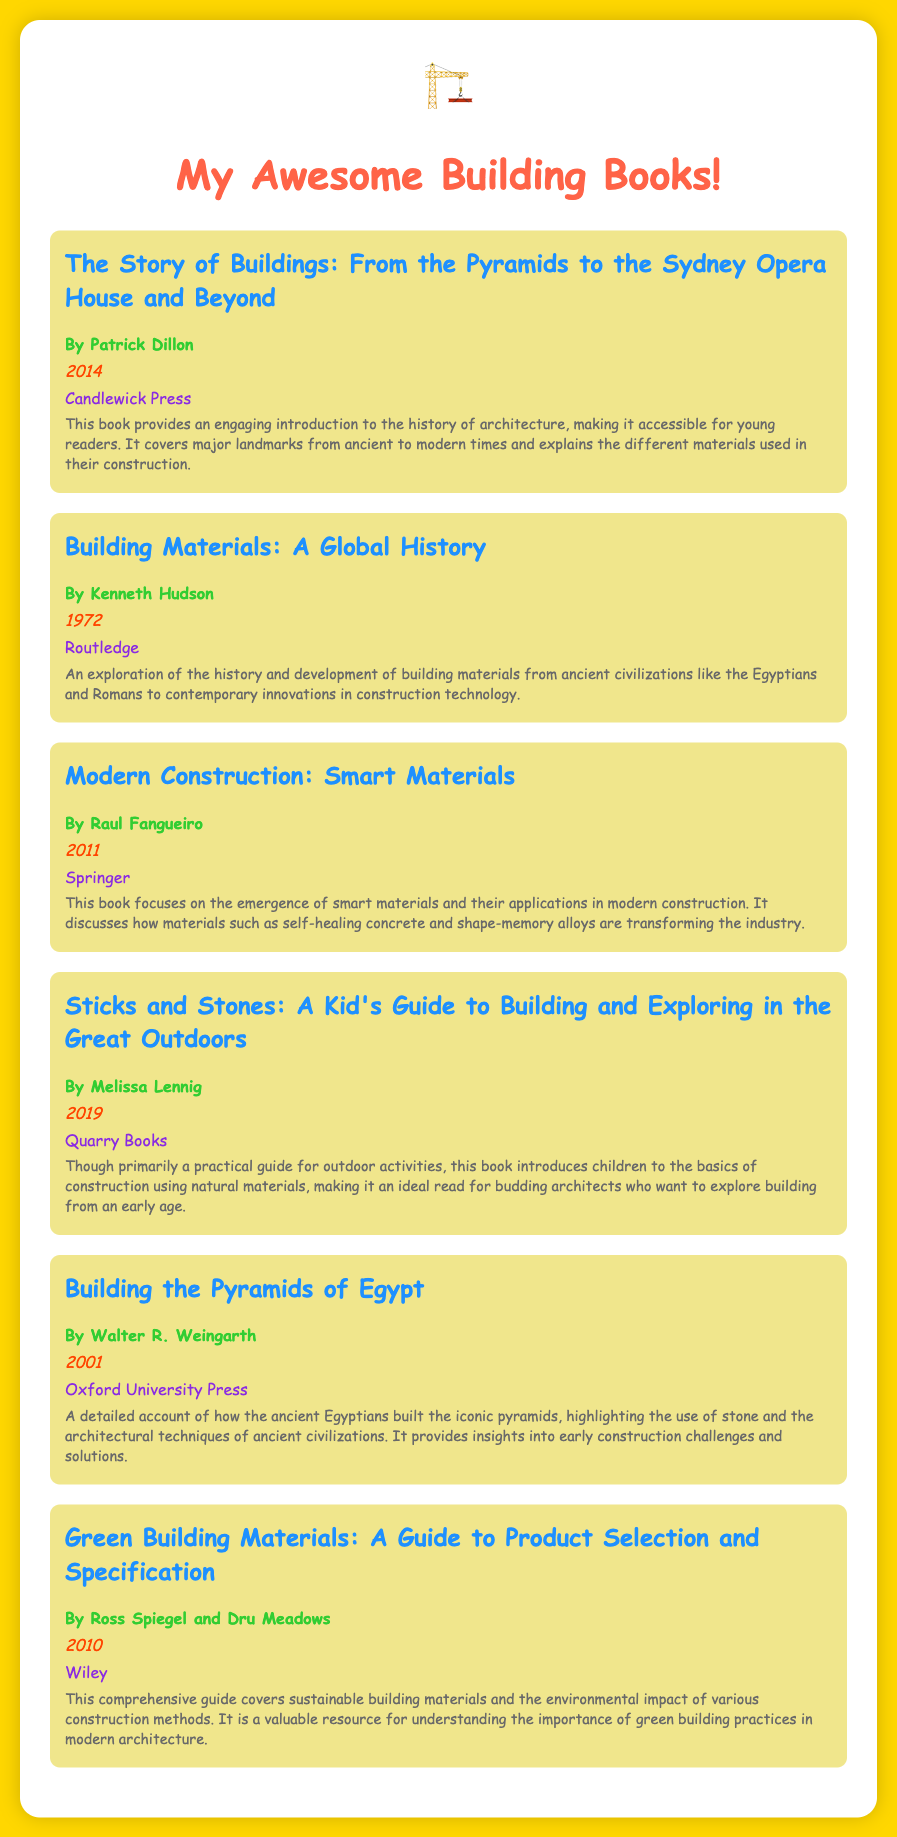What is the title of the first book? The title of the first book is the first one listed in the document, which is "The Story of Buildings: From the Pyramids to the Sydney Opera House and Beyond."
Answer: The Story of Buildings: From the Pyramids to the Sydney Opera House and Beyond Who is the author of "Building Materials: A Global History"? The author is the individual credited beneath the book's title, which is Kenneth Hudson.
Answer: Kenneth Hudson What year was "Modern Construction: Smart Materials" published? The publication year is indicated next to the author's name, which is 2011.
Answer: 2011 What type of guide does "Green Building Materials" provide? The guide described is comprehensive and covers sustainable building materials and their environmental impact.
Answer: A guide to product selection and specification Which book is primarily about outdoor construction activities? The book focused on outdoor activities is mentioned as a practical guide for children, which is "Sticks and Stones: A Kid's Guide to Building and Exploring in the Great Outdoors."
Answer: Sticks and Stones: A Kid's Guide to Building and Exploring in the Great Outdoors How many books are listed in the bibliography? The total number of books can be found by counting the individual listings in the document, which is six.
Answer: Six 